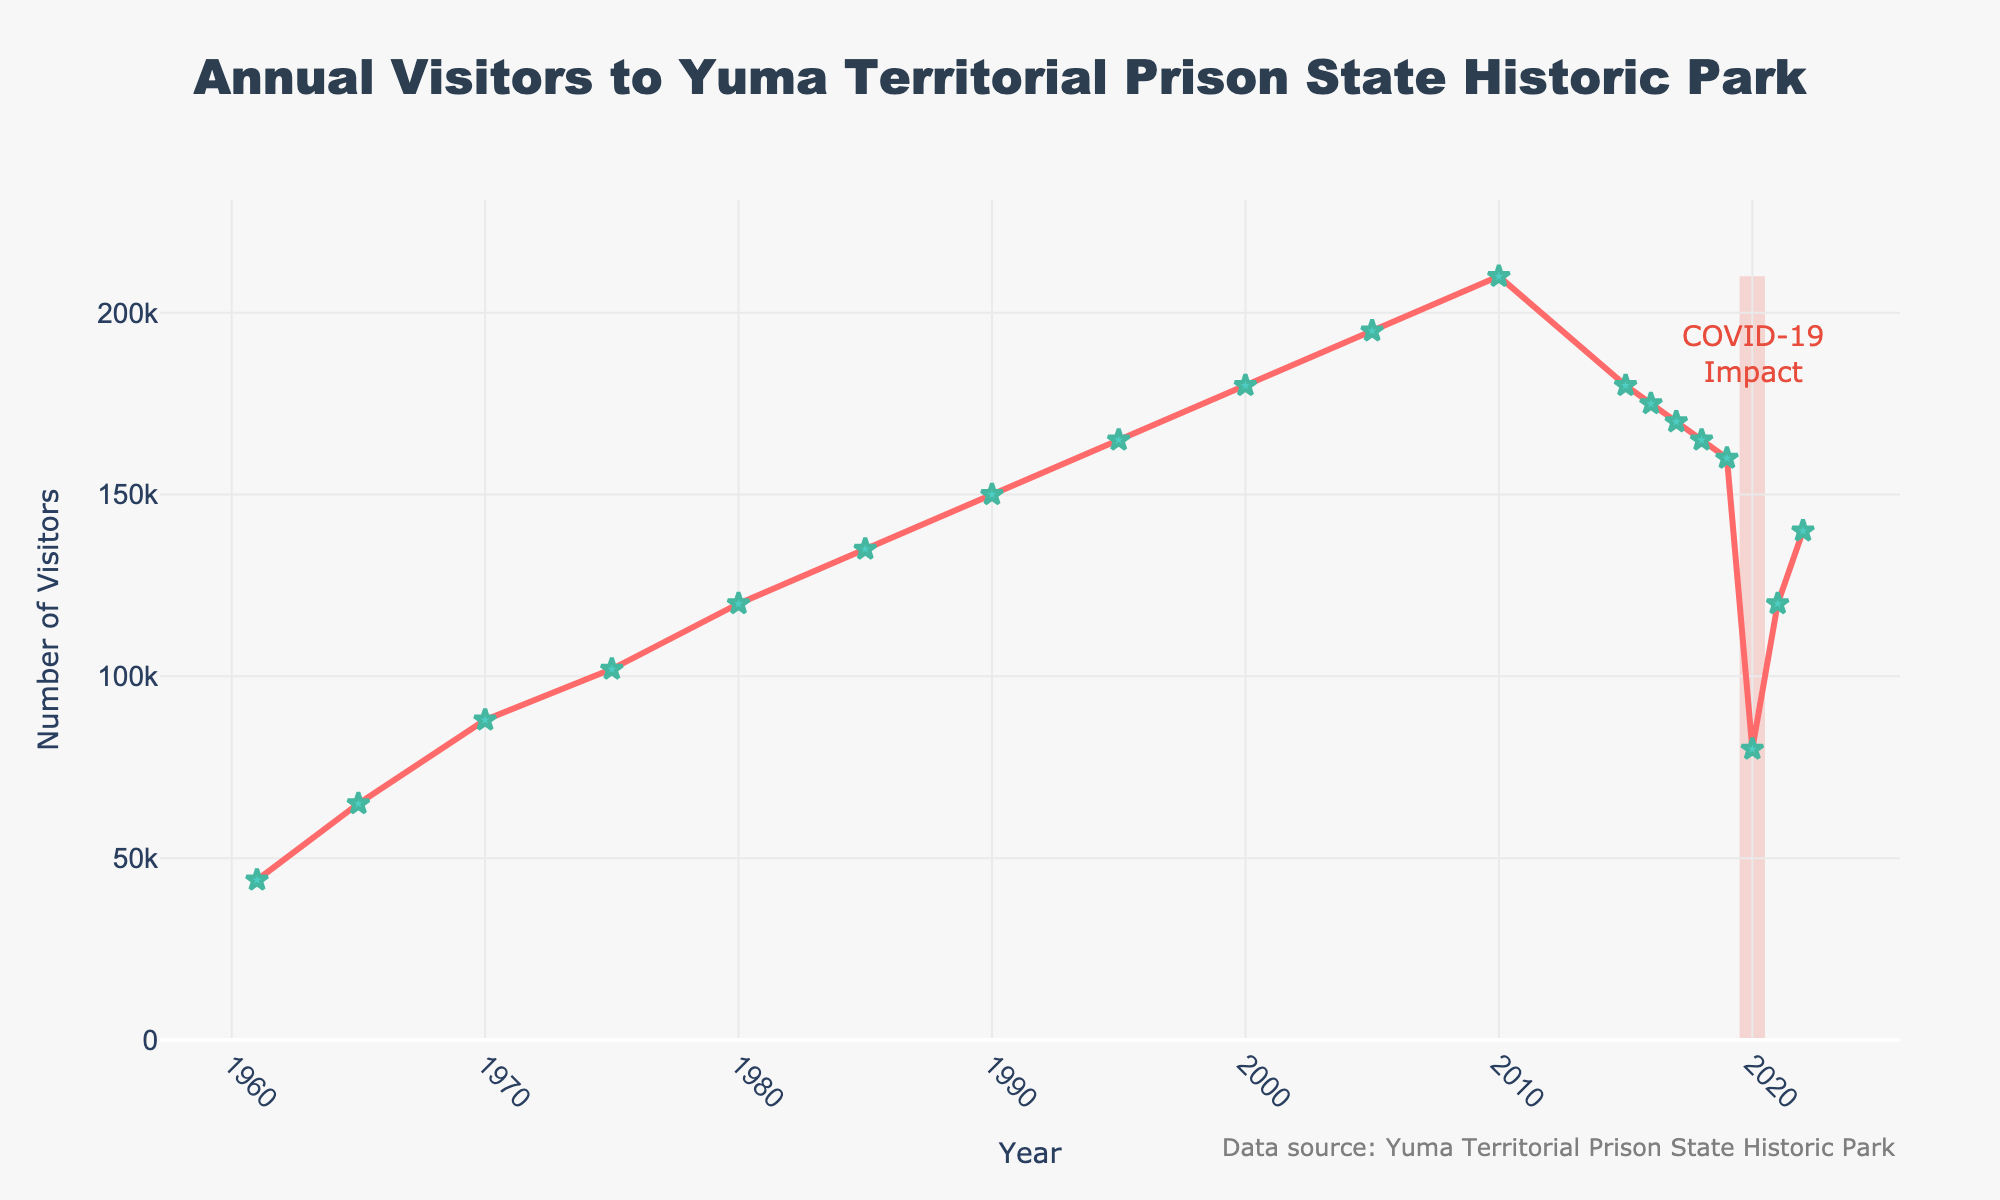What's the total number of visitors from 2015 to 2022? Sum the number of visitors for each year between 2015 and 2022: 180,000 (2015) + 175,000 (2016) + 170,000 (2017) + 165,000 (2018) + 160,000 (2019) + 80,000 (2020) + 120,000 (2021) + 140,000 (2022) = 1,190,000
Answer: 1,190,000 Which year had the highest number of visitors? Identify the peak point in the plot; the maximum value of visitors is in the year 2010 with 210,000 visitors
Answer: 2010 How did the visitor numbers change from 2019 to 2020? Look at the numbers for 2019 (160,000) and 2020 (80,000). Calculate the difference: 160,000 - 80,000 = 80,000, indicating a decline
Answer: 80,000 decline What is the average number of visitors per year between 1961 and 1980? Sum the visitors for each year in this range and divide by the number of years: (44,000 + 65,000 + 88,000 + 102,000 + 120,000) / 5 = 83,800
Answer: 83,800 Which years show a steady decline in visitor numbers after an increase in 2015? Observe the gradual decrease in visitor numbers from 2015 onwards: 2015 (180,000), 2016 (175,000), 2017 (170,000), 2018 (165,000), 2019 (160,000)
Answer: 2015 to 2019 How does the number of visitors in 1985 compare to that in 1995? Compare the values for 1985 (135,000) and 1995 (165,000). There is an increase: 165,000 - 135,000 = 30,000
Answer: 30,000 increase What is the difference in the number of visitors between the opening year (1961) and the year 2000? Subtract the number of visitors in 1961 (44,000) from those in 2000 (180,000): 180,000 - 44,000 = 136,000
Answer: 136,000 Which visual elements highlight the impact of COVID-19 on visitor numbers? The plot includes a rectangle filled with a semi-transparent red color and an annotation indicating the "COVID-19 Impact" around the year 2020, marked with a significant drop in numbers.
Answer: Rectangle and annotation What is the color and style of the line representing visitor numbers? The line is colored red with markers styled as green stars along the path.
Answer: Red line, green stars 